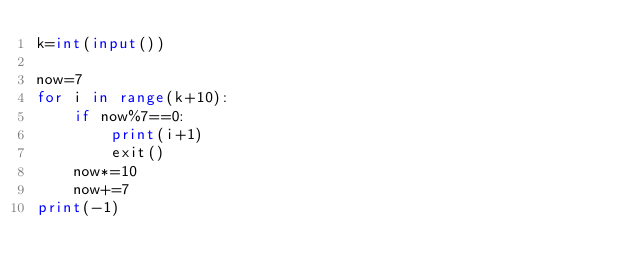Convert code to text. <code><loc_0><loc_0><loc_500><loc_500><_Python_>k=int(input())

now=7
for i in range(k+10):
	if now%7==0:
		print(i+1)
		exit()
	now*=10
	now+=7
print(-1)
    </code> 